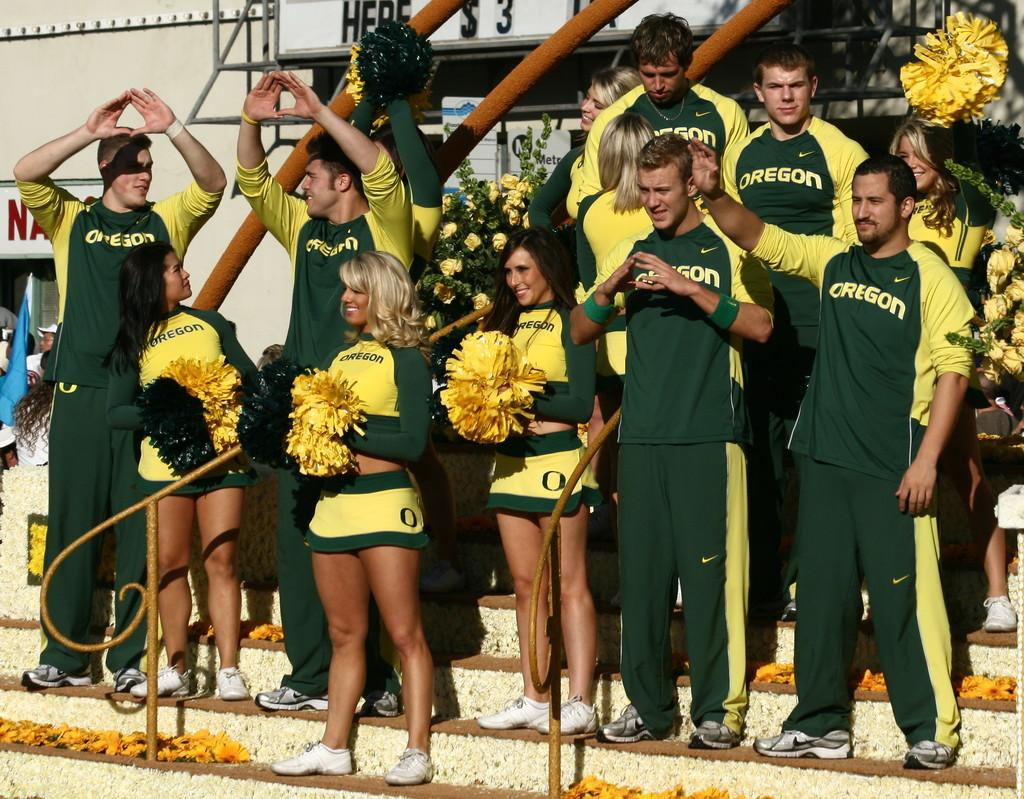<image>
Provide a brief description of the given image. Cheerleaders from oregon are in the stance cheering 